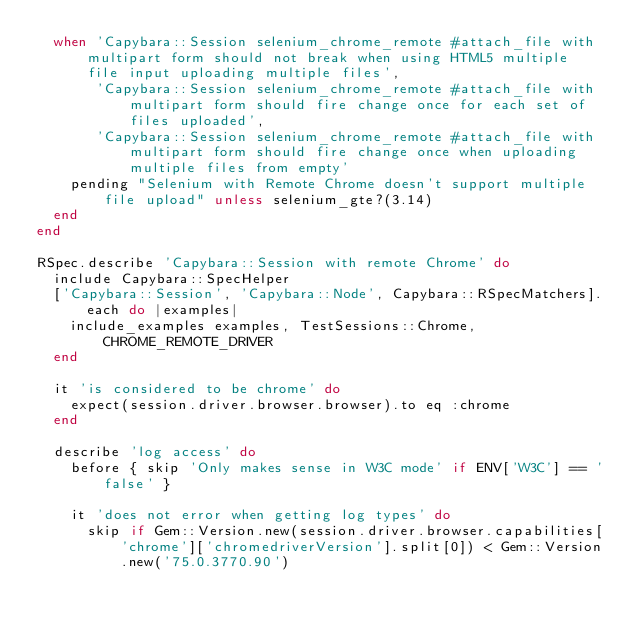<code> <loc_0><loc_0><loc_500><loc_500><_Ruby_>  when 'Capybara::Session selenium_chrome_remote #attach_file with multipart form should not break when using HTML5 multiple file input uploading multiple files',
       'Capybara::Session selenium_chrome_remote #attach_file with multipart form should fire change once for each set of files uploaded',
       'Capybara::Session selenium_chrome_remote #attach_file with multipart form should fire change once when uploading multiple files from empty'
    pending "Selenium with Remote Chrome doesn't support multiple file upload" unless selenium_gte?(3.14)
  end
end

RSpec.describe 'Capybara::Session with remote Chrome' do
  include Capybara::SpecHelper
  ['Capybara::Session', 'Capybara::Node', Capybara::RSpecMatchers].each do |examples|
    include_examples examples, TestSessions::Chrome, CHROME_REMOTE_DRIVER
  end

  it 'is considered to be chrome' do
    expect(session.driver.browser.browser).to eq :chrome
  end

  describe 'log access' do
    before { skip 'Only makes sense in W3C mode' if ENV['W3C'] == 'false' }

    it 'does not error when getting log types' do
      skip if Gem::Version.new(session.driver.browser.capabilities['chrome']['chromedriverVersion'].split[0]) < Gem::Version.new('75.0.3770.90')</code> 